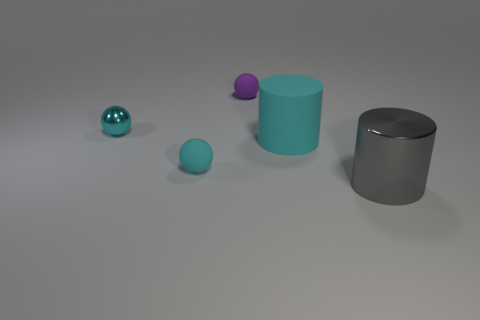What is the color of the metal object to the right of the matte sphere that is in front of the small cyan metal thing?
Offer a terse response. Gray. How many objects are the same color as the large shiny cylinder?
Make the answer very short. 0. Does the big matte cylinder have the same color as the small matte object that is in front of the tiny purple matte sphere?
Provide a succinct answer. Yes. Is the number of large metal cylinders less than the number of matte things?
Provide a succinct answer. Yes. Is the number of gray metallic cylinders that are to the left of the small cyan shiny sphere greater than the number of big gray shiny cylinders that are behind the gray cylinder?
Provide a short and direct response. No. Do the large gray cylinder and the large cyan cylinder have the same material?
Offer a terse response. No. How many purple matte things are in front of the matte ball that is in front of the purple object?
Give a very brief answer. 0. Does the large object that is left of the gray thing have the same color as the big shiny thing?
Provide a succinct answer. No. What number of objects are big cyan metal things or objects that are behind the gray cylinder?
Keep it short and to the point. 4. Is the shape of the tiny matte object that is in front of the small purple matte object the same as the shiny object to the left of the tiny purple matte object?
Provide a succinct answer. Yes. 